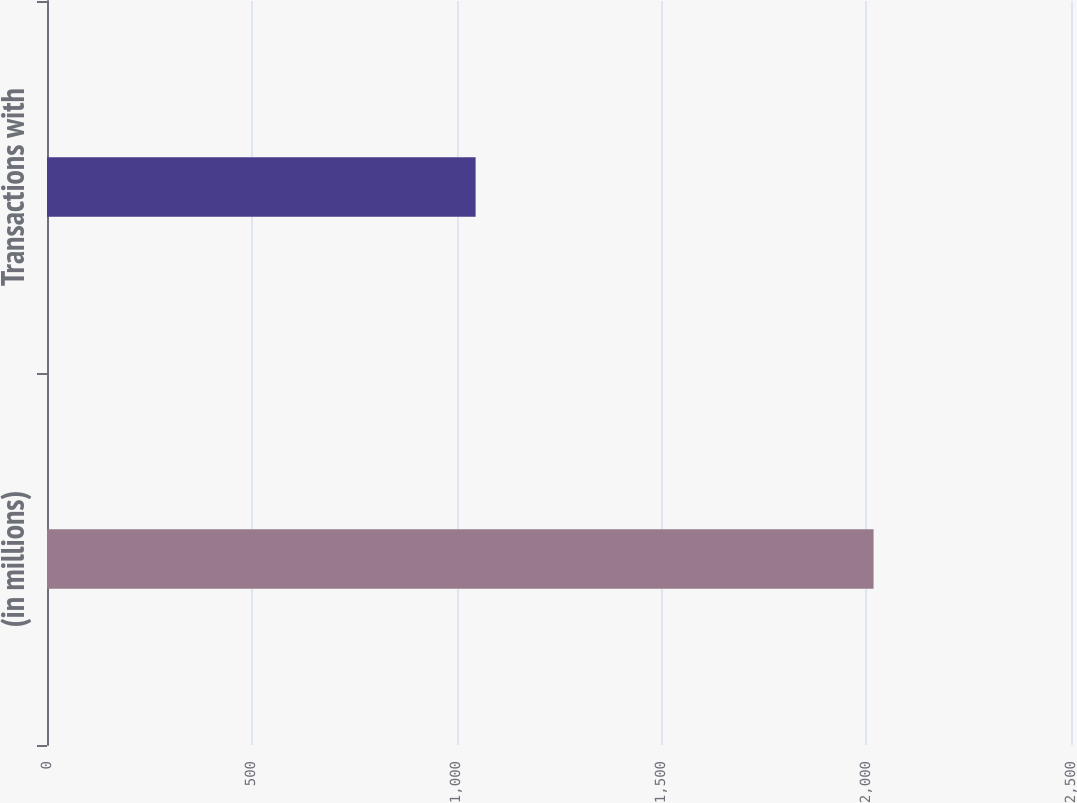Convert chart to OTSL. <chart><loc_0><loc_0><loc_500><loc_500><bar_chart><fcel>(in millions)<fcel>Transactions with<nl><fcel>2018<fcel>1046.4<nl></chart> 